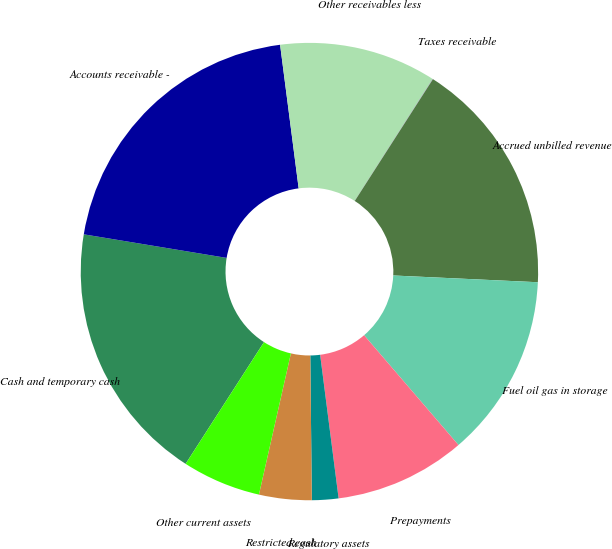<chart> <loc_0><loc_0><loc_500><loc_500><pie_chart><fcel>Cash and temporary cash<fcel>Accounts receivable -<fcel>Other receivables less<fcel>Taxes receivable<fcel>Accrued unbilled revenue<fcel>Fuel oil gas in storage<fcel>Prepayments<fcel>Regulatory assets<fcel>Restricted cash<fcel>Other current assets<nl><fcel>18.5%<fcel>20.35%<fcel>11.11%<fcel>0.02%<fcel>16.66%<fcel>12.96%<fcel>9.26%<fcel>1.87%<fcel>3.71%<fcel>5.56%<nl></chart> 